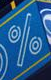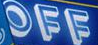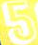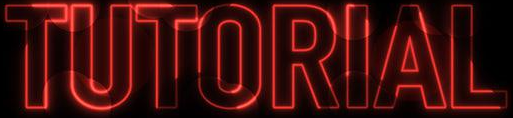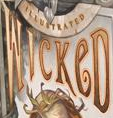Read the text content from these images in order, separated by a semicolon. %; OFF; 5; TUTORIAL; WICKeD 